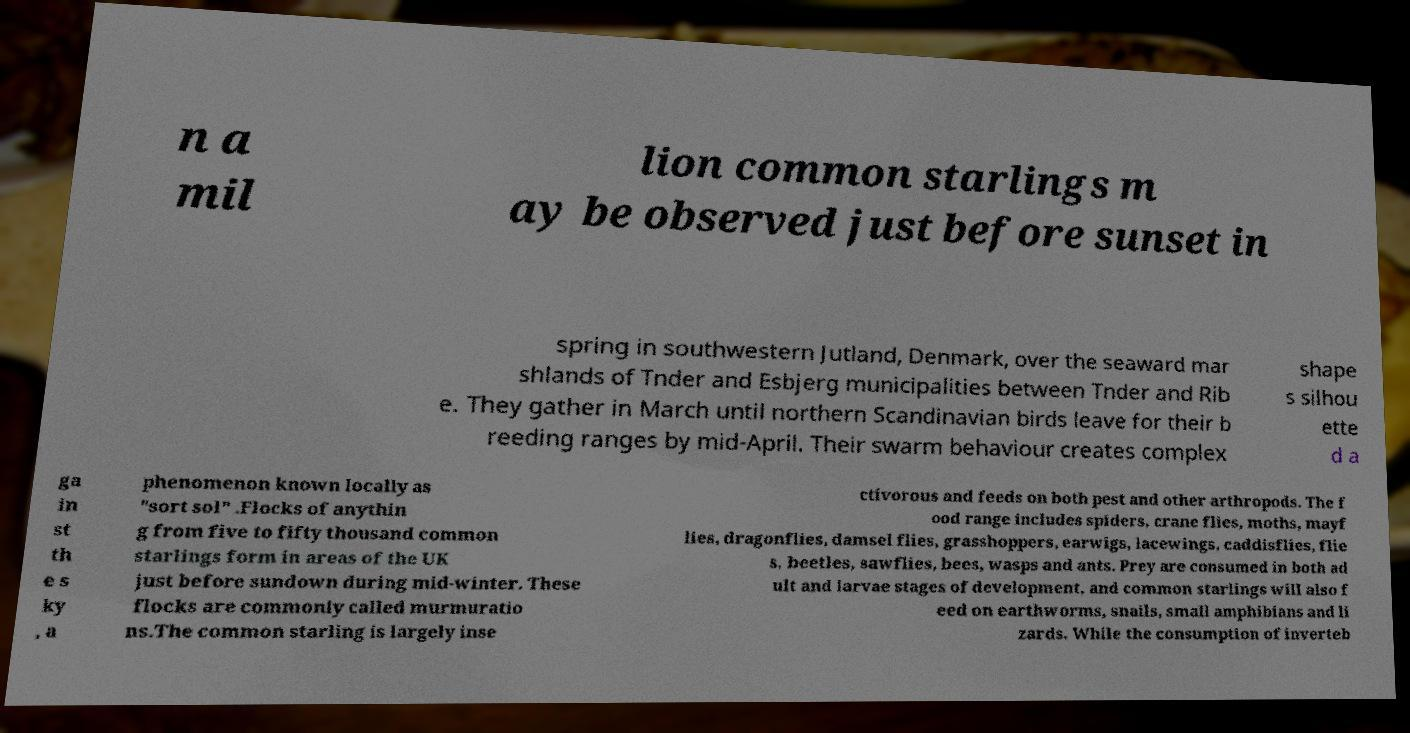Could you extract and type out the text from this image? n a mil lion common starlings m ay be observed just before sunset in spring in southwestern Jutland, Denmark, over the seaward mar shlands of Tnder and Esbjerg municipalities between Tnder and Rib e. They gather in March until northern Scandinavian birds leave for their b reeding ranges by mid-April. Their swarm behaviour creates complex shape s silhou ette d a ga in st th e s ky , a phenomenon known locally as "sort sol" .Flocks of anythin g from five to fifty thousand common starlings form in areas of the UK just before sundown during mid-winter. These flocks are commonly called murmuratio ns.The common starling is largely inse ctivorous and feeds on both pest and other arthropods. The f ood range includes spiders, crane flies, moths, mayf lies, dragonflies, damsel flies, grasshoppers, earwigs, lacewings, caddisflies, flie s, beetles, sawflies, bees, wasps and ants. Prey are consumed in both ad ult and larvae stages of development, and common starlings will also f eed on earthworms, snails, small amphibians and li zards. While the consumption of inverteb 